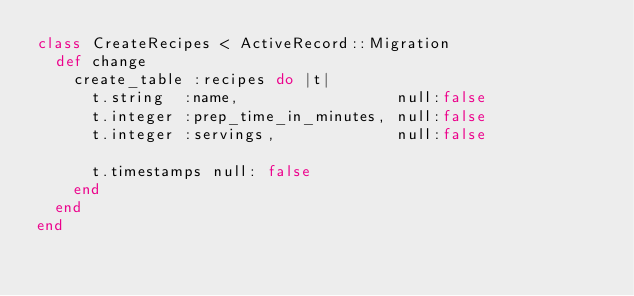<code> <loc_0><loc_0><loc_500><loc_500><_Ruby_>class CreateRecipes < ActiveRecord::Migration
  def change
    create_table :recipes do |t|
      t.string  :name,                 null:false
      t.integer :prep_time_in_minutes, null:false
      t.integer :servings,             null:false

      t.timestamps null: false
    end
  end
end
</code> 